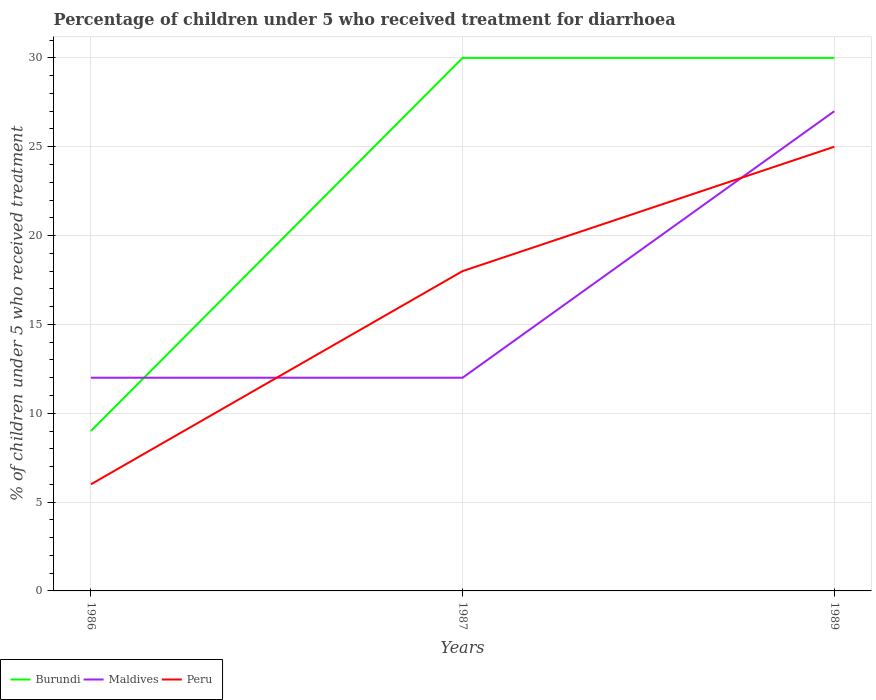How many different coloured lines are there?
Your answer should be very brief. 3. In which year was the percentage of children who received treatment for diarrhoea  in Maldives maximum?
Your answer should be very brief. 1986. What is the total percentage of children who received treatment for diarrhoea  in Maldives in the graph?
Make the answer very short. -15. What is the difference between the highest and the lowest percentage of children who received treatment for diarrhoea  in Burundi?
Provide a succinct answer. 2. Is the percentage of children who received treatment for diarrhoea  in Peru strictly greater than the percentage of children who received treatment for diarrhoea  in Maldives over the years?
Give a very brief answer. No. What is the difference between two consecutive major ticks on the Y-axis?
Provide a succinct answer. 5. Are the values on the major ticks of Y-axis written in scientific E-notation?
Your response must be concise. No. What is the title of the graph?
Provide a short and direct response. Percentage of children under 5 who received treatment for diarrhoea. Does "Monaco" appear as one of the legend labels in the graph?
Offer a very short reply. No. What is the label or title of the Y-axis?
Make the answer very short. % of children under 5 who received treatment. What is the % of children under 5 who received treatment of Burundi in 1986?
Ensure brevity in your answer.  9. What is the % of children under 5 who received treatment in Maldives in 1986?
Offer a very short reply. 12. What is the % of children under 5 who received treatment in Peru in 1986?
Provide a succinct answer. 6. What is the % of children under 5 who received treatment in Maldives in 1989?
Your answer should be compact. 27. Across all years, what is the maximum % of children under 5 who received treatment of Burundi?
Your answer should be very brief. 30. Across all years, what is the maximum % of children under 5 who received treatment of Maldives?
Your answer should be very brief. 27. Across all years, what is the maximum % of children under 5 who received treatment in Peru?
Give a very brief answer. 25. Across all years, what is the minimum % of children under 5 who received treatment in Maldives?
Make the answer very short. 12. Across all years, what is the minimum % of children under 5 who received treatment of Peru?
Give a very brief answer. 6. What is the difference between the % of children under 5 who received treatment in Peru in 1986 and that in 1987?
Your answer should be very brief. -12. What is the difference between the % of children under 5 who received treatment of Maldives in 1986 and that in 1989?
Provide a short and direct response. -15. What is the difference between the % of children under 5 who received treatment of Peru in 1986 and that in 1989?
Keep it short and to the point. -19. What is the difference between the % of children under 5 who received treatment of Burundi in 1986 and the % of children under 5 who received treatment of Peru in 1987?
Provide a short and direct response. -9. What is the difference between the % of children under 5 who received treatment of Burundi in 1986 and the % of children under 5 who received treatment of Maldives in 1989?
Ensure brevity in your answer.  -18. What is the difference between the % of children under 5 who received treatment in Maldives in 1986 and the % of children under 5 who received treatment in Peru in 1989?
Keep it short and to the point. -13. What is the difference between the % of children under 5 who received treatment in Burundi in 1987 and the % of children under 5 who received treatment in Maldives in 1989?
Provide a succinct answer. 3. What is the difference between the % of children under 5 who received treatment in Burundi in 1987 and the % of children under 5 who received treatment in Peru in 1989?
Your answer should be very brief. 5. What is the difference between the % of children under 5 who received treatment of Maldives in 1987 and the % of children under 5 who received treatment of Peru in 1989?
Your answer should be compact. -13. What is the average % of children under 5 who received treatment of Burundi per year?
Your answer should be compact. 23. What is the average % of children under 5 who received treatment of Peru per year?
Your answer should be compact. 16.33. In the year 1986, what is the difference between the % of children under 5 who received treatment in Burundi and % of children under 5 who received treatment in Peru?
Provide a succinct answer. 3. In the year 1987, what is the difference between the % of children under 5 who received treatment of Maldives and % of children under 5 who received treatment of Peru?
Offer a very short reply. -6. In the year 1989, what is the difference between the % of children under 5 who received treatment in Maldives and % of children under 5 who received treatment in Peru?
Offer a very short reply. 2. What is the ratio of the % of children under 5 who received treatment in Burundi in 1986 to that in 1987?
Your answer should be compact. 0.3. What is the ratio of the % of children under 5 who received treatment of Burundi in 1986 to that in 1989?
Provide a short and direct response. 0.3. What is the ratio of the % of children under 5 who received treatment in Maldives in 1986 to that in 1989?
Make the answer very short. 0.44. What is the ratio of the % of children under 5 who received treatment of Peru in 1986 to that in 1989?
Your response must be concise. 0.24. What is the ratio of the % of children under 5 who received treatment in Maldives in 1987 to that in 1989?
Provide a short and direct response. 0.44. What is the ratio of the % of children under 5 who received treatment of Peru in 1987 to that in 1989?
Keep it short and to the point. 0.72. What is the difference between the highest and the second highest % of children under 5 who received treatment of Peru?
Provide a succinct answer. 7. What is the difference between the highest and the lowest % of children under 5 who received treatment in Burundi?
Offer a very short reply. 21. What is the difference between the highest and the lowest % of children under 5 who received treatment of Maldives?
Make the answer very short. 15. 